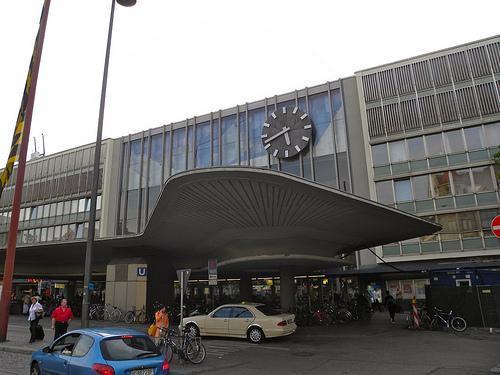How many cars?
Give a very brief answer. 2. How many people are wearing in orange?
Give a very brief answer. 1. 